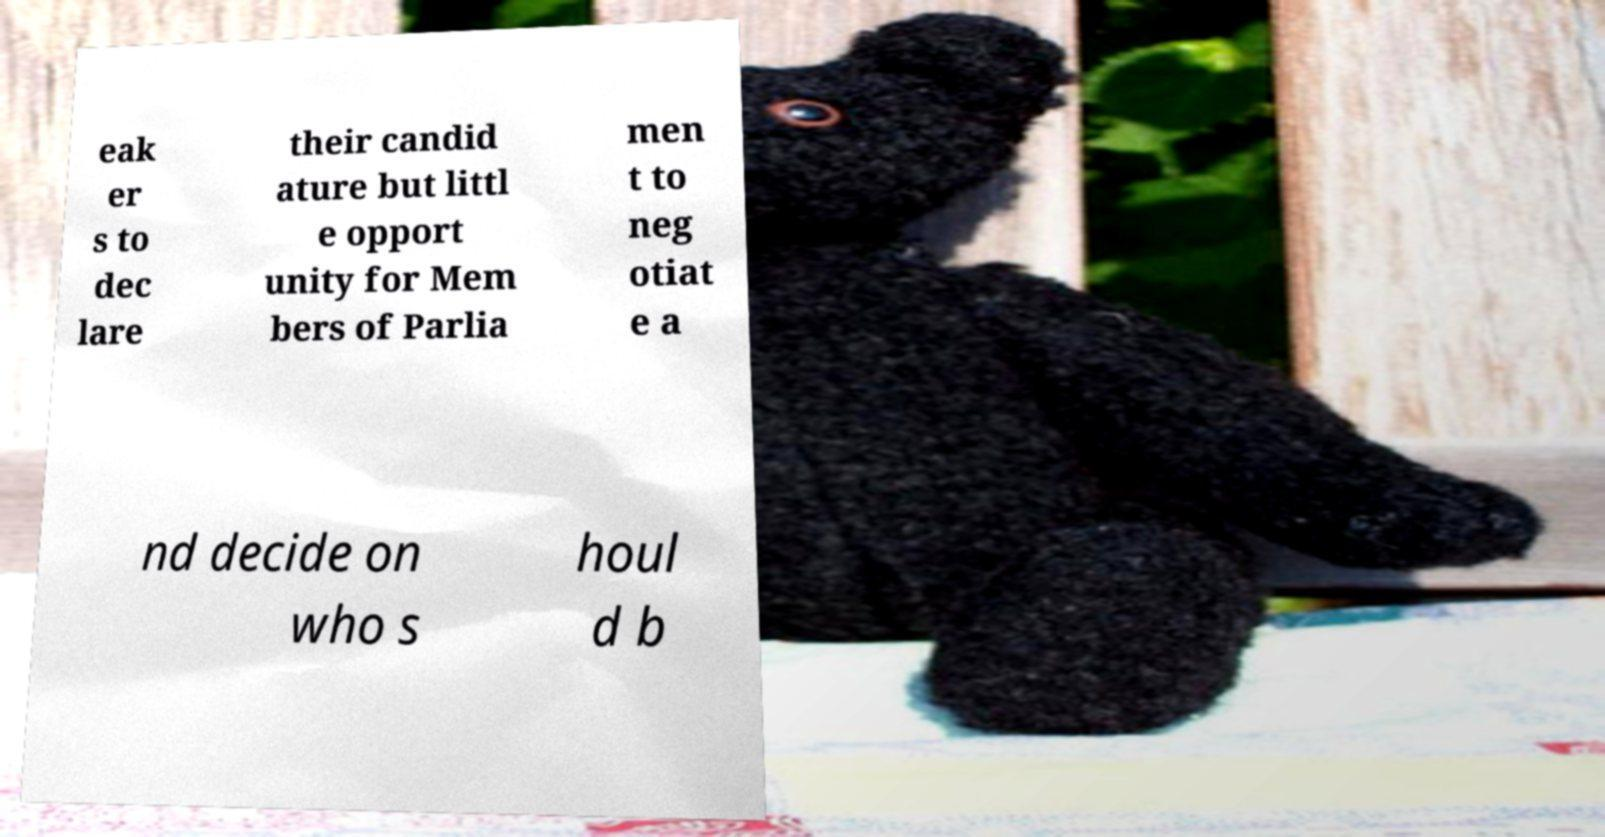Please read and relay the text visible in this image. What does it say? eak er s to dec lare their candid ature but littl e opport unity for Mem bers of Parlia men t to neg otiat e a nd decide on who s houl d b 